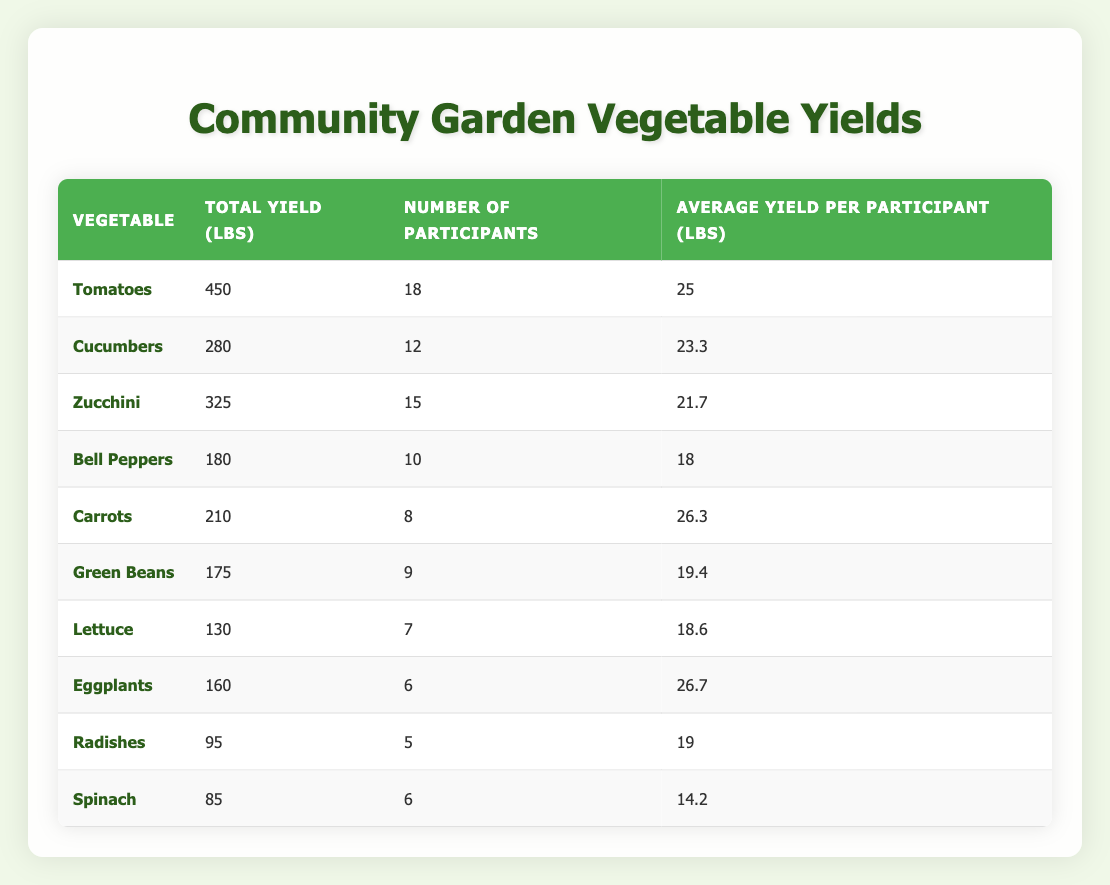What is the total yield of tomatoes? The total yield of tomatoes can be found directly in the table under the Total Yield column. It lists 450 lbs next to tomatoes.
Answer: 450 lbs How many participants grew eggplants? The number of participants who grew eggplants is indicated in the table next to eggplants, which lists 6 participants.
Answer: 6 Which vegetable had the highest average yield per participant? To find the vegetable with the highest average yield per participant, we compare the Average Yield per Participant column. The maximum value is 26.7 lbs next to eggplants.
Answer: Eggplants What is the total yield of cucumbers and bell peppers combined? To find the combined total yield, we look up the yields: cucumbers have 280 lbs and bell peppers have 180 lbs. Adding these gives 280 + 180 = 460 lbs.
Answer: 460 lbs Is the average yield of spinach higher than that of lettuce? The average yield for spinach is 14.2 lbs and for lettuce is 18.6 lbs. Since 14.2 is less than 18.6, the statement is false.
Answer: No What was the total number of participants across all vegetables? We sum the number of participants for each vegetable: 18 (tomatoes) + 12 (cucumbers) + 15 (zucchini) + 10 (bell peppers) + 8 (carrots) + 9 (green beans) + 7 (lettuce) + 6 (eggplants) + 5 (radishes) + 6 (spinach) = 96 participants in total.
Answer: 96 Which vegetable had the lowest total yield? The vegetable with the lowest total yield is listed with 85 lbs, which corresponds to spinach according to the Total Yield column.
Answer: Spinach What is the average yield per participant for carrots and cucumbers combined? First, we find the average yields: carrots have 26.3 lbs and cucumbers have 23.3 lbs. The combined average is (26.3 + 23.3) / 2 = 24.8 lbs.
Answer: 24.8 lbs 